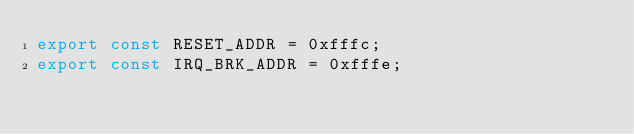<code> <loc_0><loc_0><loc_500><loc_500><_JavaScript_>export const RESET_ADDR = 0xfffc;
export const IRQ_BRK_ADDR = 0xfffe;
</code> 